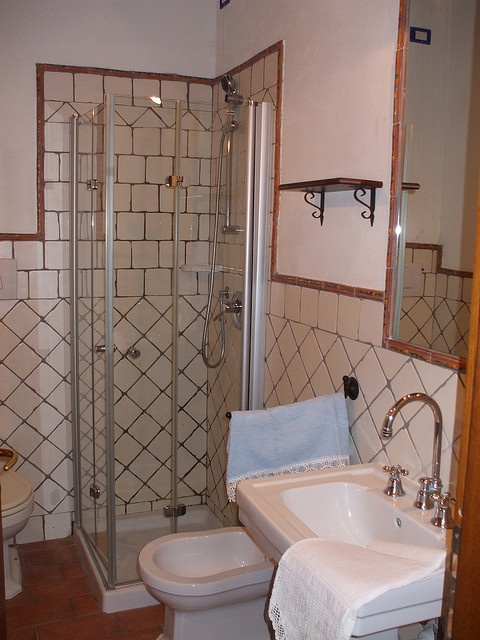Describe the objects in this image and their specific colors. I can see sink in gray, darkgray, and lightgray tones, toilet in gray tones, and toilet in gray and maroon tones in this image. 